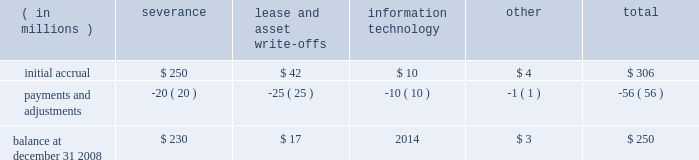As described above , the borrowings are extended on a non-recourse basis .
As such , there is no credit or market risk exposure to us on the assets , and as a result the terms of the amlf permit exclusion of the assets from regulatory leverage and risk-based capital calculations .
The interest rate on the borrowings is set by the federal reserve bank , and we earn net interest revenue by earning a spread on the difference between the yield we earn on the assets and the rate we pay on the borrowings .
For 2008 , we earned net interest revenue associated with this facility of approximately $ 68 million .
Separately , we currently maintain a commercial paper program under which we can issue up to $ 3 billion with original maturities of up to 270 days from the date of issue .
At december 31 , 2008 and 2007 , $ 2.59 billion and $ 2.36 billion , respectively , of commercial paper were outstanding .
In addition , state street bank currently has board authority to issue bank notes up to an aggregate of $ 5 billion , including up to $ 2.48 billion of senior notes under the fdic 2019s temporary liquidity guarantee program , instituted by the fdic in october 2008 for qualified senior debt issued through june 30 , 2009 , and up to $ 1 billion of subordinated bank notes ( see note 10 ) .
At december 31 , 2008 and 2007 , no notes payable were outstanding , and at december 31 , 2008 , all $ 5 billion was available for issuance .
State street bank currently maintains a line of credit of cad $ 800 million , or approximately $ 657 million , to support its canadian securities processing operations .
The line of credit has no stated termination date and is cancelable by either party with prior notice .
At december 31 , 2008 , no balance was due on this line of credit .
Note 9 .
Restructuring charges in december 2008 , we implemented a plan to reduce our expenses from operations and support our long- term growth .
In connection with this plan , we recorded aggregate restructuring charges of $ 306 million in our consolidated statement of income .
The primary component of the plan was an involuntary reduction of approximately 7% ( 7 % ) of our global workforce , which reduction we expect to be substantially completed by the end of the first quarter of 2009 .
Other components of the plan included costs related to lease and software license terminations , restructuring of agreements with technology providers and other costs .
Of the aggregate restructuring charges of $ 306 million , $ 243 million related to severance , a portion of which will be paid in a lump sum or over a defined period , and a portion of which will provide related benefits and outplacement services for approximately 2100 employees identified for involuntary termination in connection with the plan ; $ 49 million related to future lease obligations and write-offs of capitalized assets , including $ 23 million for impairment of other intangible assets ; $ 10 million of costs associated with information technology and $ 4 million of other restructuring costs .
The severance component included $ 47 million related to accelerated vesting of equity-based compensation .
In december 2008 , approximately 620 employees were involuntarily terminated and left state street .
The table presents the activity in the related balance sheet reserve for 2008 .
( in millions ) severance lease and write-offs information technology other total .

What portion of the balance of initial accrual is related to severances? 
Computations: (250 / 306)
Answer: 0.81699. 